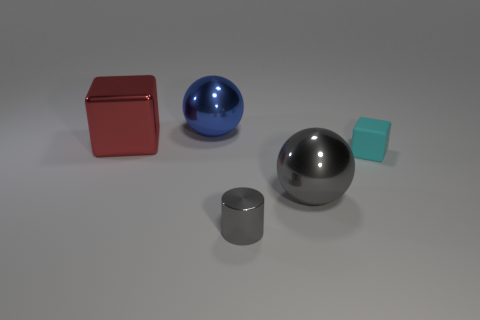Does the small block have the same color as the sphere on the left side of the tiny cylinder?
Give a very brief answer. No. What number of objects are left of the cyan matte cube?
Offer a terse response. 4. Is the number of shiny things in front of the metal cylinder less than the number of blue shiny objects?
Your response must be concise. Yes. The rubber cube has what color?
Give a very brief answer. Cyan. There is a large shiny thing in front of the tiny cyan object; does it have the same color as the rubber object?
Your answer should be compact. No. There is another big shiny object that is the same shape as the blue thing; what color is it?
Provide a short and direct response. Gray. What number of large objects are metallic objects or shiny cylinders?
Make the answer very short. 3. What size is the metallic ball that is right of the metallic cylinder?
Your answer should be compact. Large. Are there any things of the same color as the tiny metal cylinder?
Ensure brevity in your answer.  Yes. Do the large block and the tiny cylinder have the same color?
Your answer should be compact. No. 